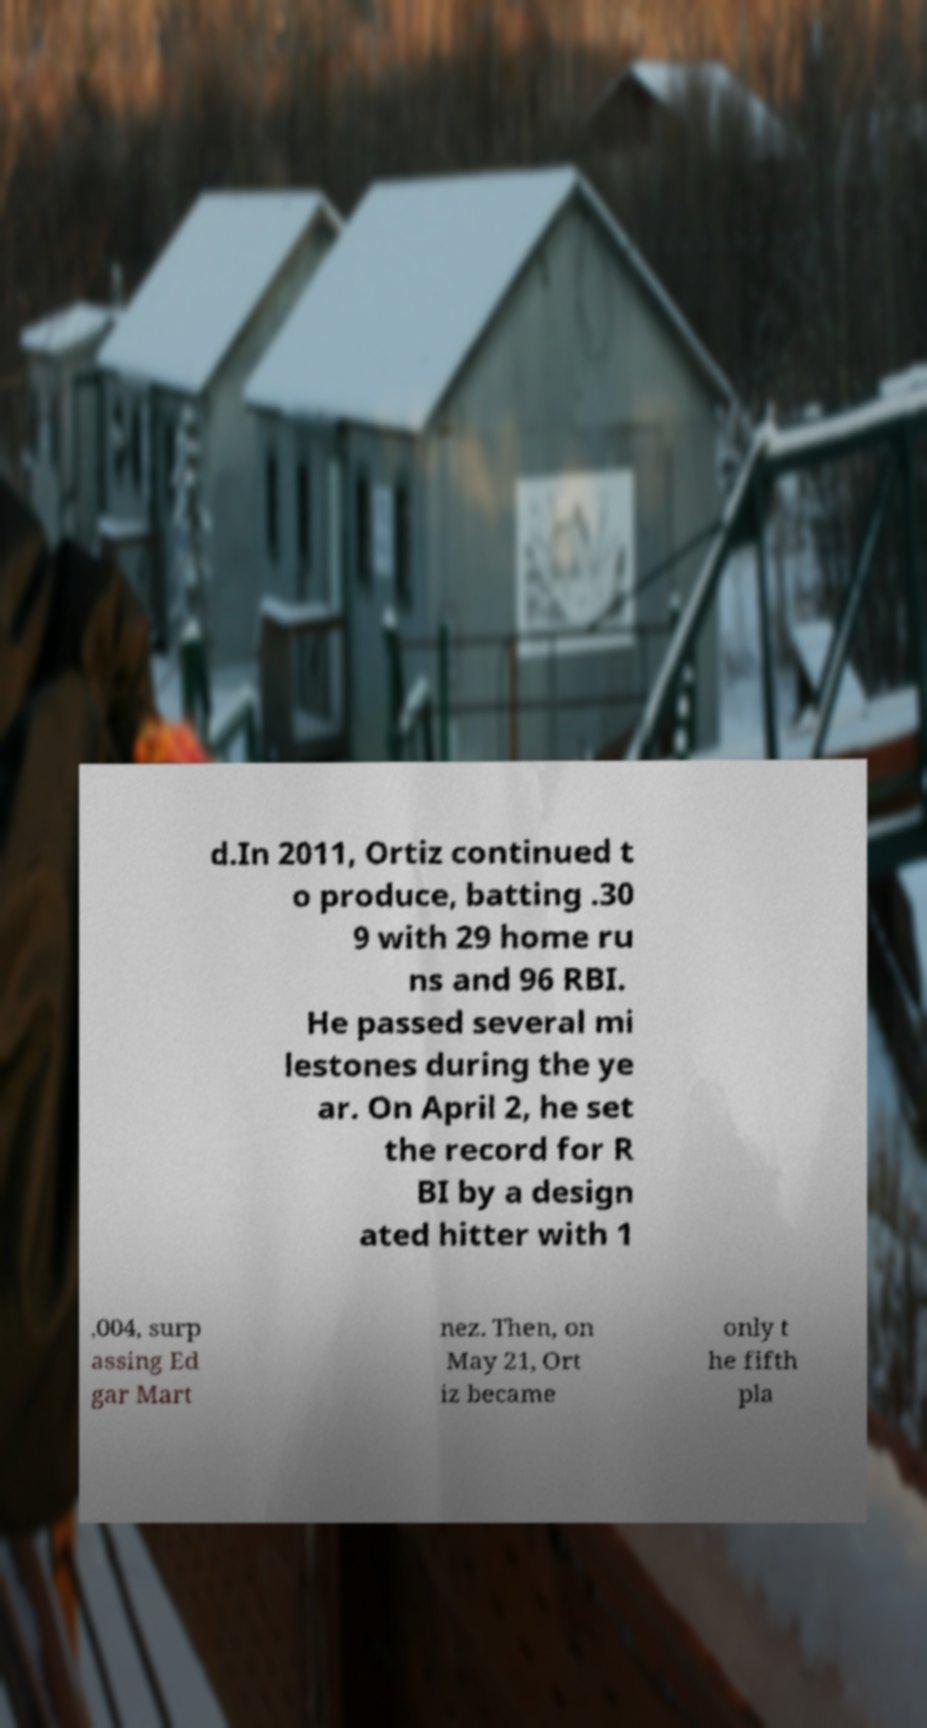Please read and relay the text visible in this image. What does it say? d.In 2011, Ortiz continued t o produce, batting .30 9 with 29 home ru ns and 96 RBI. He passed several mi lestones during the ye ar. On April 2, he set the record for R BI by a design ated hitter with 1 ,004, surp assing Ed gar Mart nez. Then, on May 21, Ort iz became only t he fifth pla 